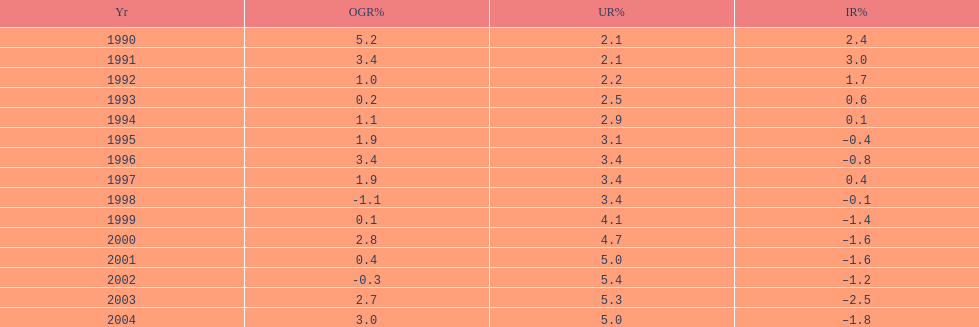Were the highest unemployment rates in japan before or after the year 2000? After. I'm looking to parse the entire table for insights. Could you assist me with that? {'header': ['Yr', 'OGR%', 'UR%', 'IR%'], 'rows': [['1990', '5.2', '2.1', '2.4'], ['1991', '3.4', '2.1', '3.0'], ['1992', '1.0', '2.2', '1.7'], ['1993', '0.2', '2.5', '0.6'], ['1994', '1.1', '2.9', '0.1'], ['1995', '1.9', '3.1', '–0.4'], ['1996', '3.4', '3.4', '–0.8'], ['1997', '1.9', '3.4', '0.4'], ['1998', '-1.1', '3.4', '–0.1'], ['1999', '0.1', '4.1', '–1.4'], ['2000', '2.8', '4.7', '–1.6'], ['2001', '0.4', '5.0', '–1.6'], ['2002', '-0.3', '5.4', '–1.2'], ['2003', '2.7', '5.3', '–2.5'], ['2004', '3.0', '5.0', '–1.8']]} 